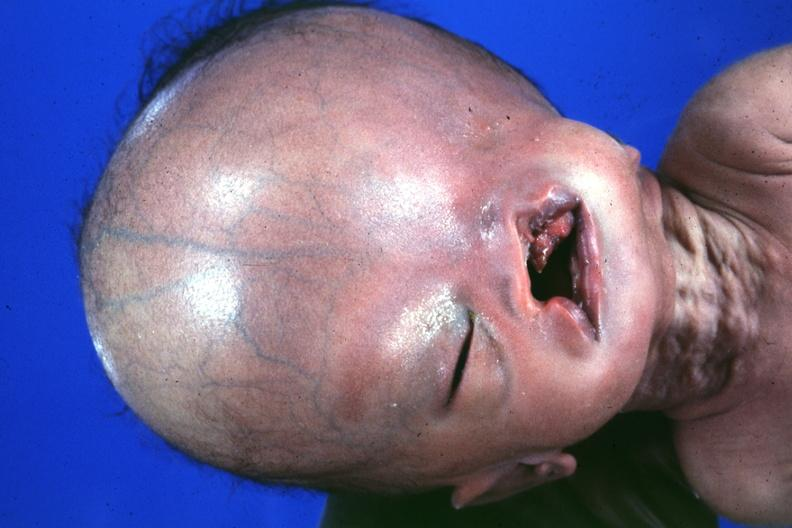what does this image show?
Answer the question using a single word or phrase. Absence of palpebral fissure cleft palate large head see protocol for details 